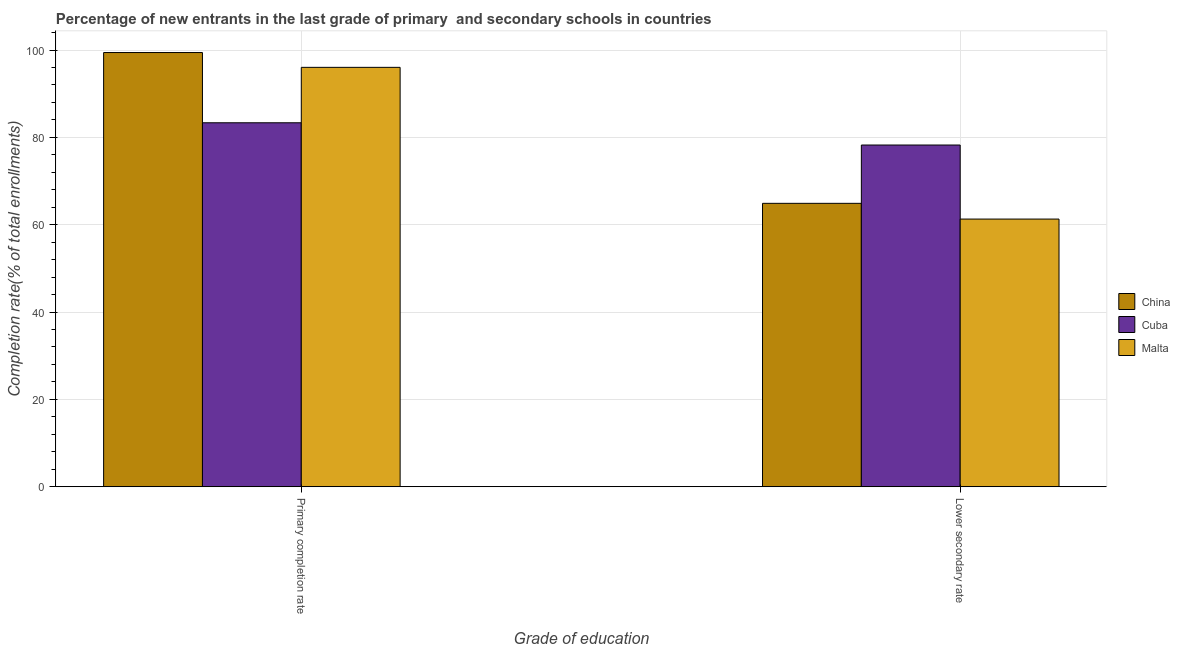How many different coloured bars are there?
Offer a very short reply. 3. Are the number of bars per tick equal to the number of legend labels?
Your answer should be very brief. Yes. Are the number of bars on each tick of the X-axis equal?
Make the answer very short. Yes. How many bars are there on the 1st tick from the left?
Offer a very short reply. 3. How many bars are there on the 1st tick from the right?
Provide a short and direct response. 3. What is the label of the 1st group of bars from the left?
Make the answer very short. Primary completion rate. What is the completion rate in secondary schools in Cuba?
Make the answer very short. 78.24. Across all countries, what is the maximum completion rate in secondary schools?
Offer a terse response. 78.24. Across all countries, what is the minimum completion rate in primary schools?
Make the answer very short. 83.34. In which country was the completion rate in primary schools maximum?
Provide a succinct answer. China. In which country was the completion rate in secondary schools minimum?
Keep it short and to the point. Malta. What is the total completion rate in secondary schools in the graph?
Give a very brief answer. 204.42. What is the difference between the completion rate in secondary schools in Cuba and that in Malta?
Offer a very short reply. 16.96. What is the difference between the completion rate in secondary schools in China and the completion rate in primary schools in Cuba?
Offer a terse response. -18.45. What is the average completion rate in secondary schools per country?
Your answer should be very brief. 68.14. What is the difference between the completion rate in secondary schools and completion rate in primary schools in Malta?
Offer a terse response. -34.74. In how many countries, is the completion rate in primary schools greater than 28 %?
Ensure brevity in your answer.  3. What is the ratio of the completion rate in primary schools in Malta to that in Cuba?
Your answer should be very brief. 1.15. Is the completion rate in secondary schools in China less than that in Cuba?
Provide a succinct answer. Yes. What does the 2nd bar from the left in Primary completion rate represents?
Your answer should be compact. Cuba. What does the 2nd bar from the right in Primary completion rate represents?
Provide a short and direct response. Cuba. How many bars are there?
Give a very brief answer. 6. Are all the bars in the graph horizontal?
Offer a terse response. No. Are the values on the major ticks of Y-axis written in scientific E-notation?
Provide a succinct answer. No. Does the graph contain grids?
Make the answer very short. Yes. How are the legend labels stacked?
Your response must be concise. Vertical. What is the title of the graph?
Your response must be concise. Percentage of new entrants in the last grade of primary  and secondary schools in countries. What is the label or title of the X-axis?
Provide a succinct answer. Grade of education. What is the label or title of the Y-axis?
Provide a short and direct response. Completion rate(% of total enrollments). What is the Completion rate(% of total enrollments) in China in Primary completion rate?
Your answer should be very brief. 99.42. What is the Completion rate(% of total enrollments) of Cuba in Primary completion rate?
Provide a short and direct response. 83.34. What is the Completion rate(% of total enrollments) of Malta in Primary completion rate?
Your answer should be compact. 96.03. What is the Completion rate(% of total enrollments) of China in Lower secondary rate?
Ensure brevity in your answer.  64.89. What is the Completion rate(% of total enrollments) of Cuba in Lower secondary rate?
Your answer should be compact. 78.24. What is the Completion rate(% of total enrollments) in Malta in Lower secondary rate?
Your answer should be very brief. 61.29. Across all Grade of education, what is the maximum Completion rate(% of total enrollments) in China?
Your answer should be very brief. 99.42. Across all Grade of education, what is the maximum Completion rate(% of total enrollments) in Cuba?
Offer a terse response. 83.34. Across all Grade of education, what is the maximum Completion rate(% of total enrollments) in Malta?
Offer a terse response. 96.03. Across all Grade of education, what is the minimum Completion rate(% of total enrollments) in China?
Offer a terse response. 64.89. Across all Grade of education, what is the minimum Completion rate(% of total enrollments) in Cuba?
Make the answer very short. 78.24. Across all Grade of education, what is the minimum Completion rate(% of total enrollments) of Malta?
Make the answer very short. 61.29. What is the total Completion rate(% of total enrollments) of China in the graph?
Give a very brief answer. 164.31. What is the total Completion rate(% of total enrollments) of Cuba in the graph?
Provide a succinct answer. 161.58. What is the total Completion rate(% of total enrollments) in Malta in the graph?
Keep it short and to the point. 157.32. What is the difference between the Completion rate(% of total enrollments) in China in Primary completion rate and that in Lower secondary rate?
Make the answer very short. 34.53. What is the difference between the Completion rate(% of total enrollments) in Cuba in Primary completion rate and that in Lower secondary rate?
Provide a short and direct response. 5.09. What is the difference between the Completion rate(% of total enrollments) in Malta in Primary completion rate and that in Lower secondary rate?
Offer a terse response. 34.74. What is the difference between the Completion rate(% of total enrollments) in China in Primary completion rate and the Completion rate(% of total enrollments) in Cuba in Lower secondary rate?
Make the answer very short. 21.18. What is the difference between the Completion rate(% of total enrollments) of China in Primary completion rate and the Completion rate(% of total enrollments) of Malta in Lower secondary rate?
Offer a terse response. 38.13. What is the difference between the Completion rate(% of total enrollments) in Cuba in Primary completion rate and the Completion rate(% of total enrollments) in Malta in Lower secondary rate?
Offer a terse response. 22.05. What is the average Completion rate(% of total enrollments) of China per Grade of education?
Offer a very short reply. 82.16. What is the average Completion rate(% of total enrollments) in Cuba per Grade of education?
Ensure brevity in your answer.  80.79. What is the average Completion rate(% of total enrollments) of Malta per Grade of education?
Your response must be concise. 78.66. What is the difference between the Completion rate(% of total enrollments) of China and Completion rate(% of total enrollments) of Cuba in Primary completion rate?
Provide a short and direct response. 16.08. What is the difference between the Completion rate(% of total enrollments) in China and Completion rate(% of total enrollments) in Malta in Primary completion rate?
Provide a short and direct response. 3.39. What is the difference between the Completion rate(% of total enrollments) of Cuba and Completion rate(% of total enrollments) of Malta in Primary completion rate?
Offer a very short reply. -12.69. What is the difference between the Completion rate(% of total enrollments) of China and Completion rate(% of total enrollments) of Cuba in Lower secondary rate?
Keep it short and to the point. -13.35. What is the difference between the Completion rate(% of total enrollments) of China and Completion rate(% of total enrollments) of Malta in Lower secondary rate?
Make the answer very short. 3.6. What is the difference between the Completion rate(% of total enrollments) of Cuba and Completion rate(% of total enrollments) of Malta in Lower secondary rate?
Keep it short and to the point. 16.96. What is the ratio of the Completion rate(% of total enrollments) of China in Primary completion rate to that in Lower secondary rate?
Provide a short and direct response. 1.53. What is the ratio of the Completion rate(% of total enrollments) of Cuba in Primary completion rate to that in Lower secondary rate?
Give a very brief answer. 1.07. What is the ratio of the Completion rate(% of total enrollments) in Malta in Primary completion rate to that in Lower secondary rate?
Provide a succinct answer. 1.57. What is the difference between the highest and the second highest Completion rate(% of total enrollments) of China?
Keep it short and to the point. 34.53. What is the difference between the highest and the second highest Completion rate(% of total enrollments) in Cuba?
Provide a succinct answer. 5.09. What is the difference between the highest and the second highest Completion rate(% of total enrollments) in Malta?
Ensure brevity in your answer.  34.74. What is the difference between the highest and the lowest Completion rate(% of total enrollments) of China?
Offer a terse response. 34.53. What is the difference between the highest and the lowest Completion rate(% of total enrollments) of Cuba?
Provide a succinct answer. 5.09. What is the difference between the highest and the lowest Completion rate(% of total enrollments) in Malta?
Ensure brevity in your answer.  34.74. 